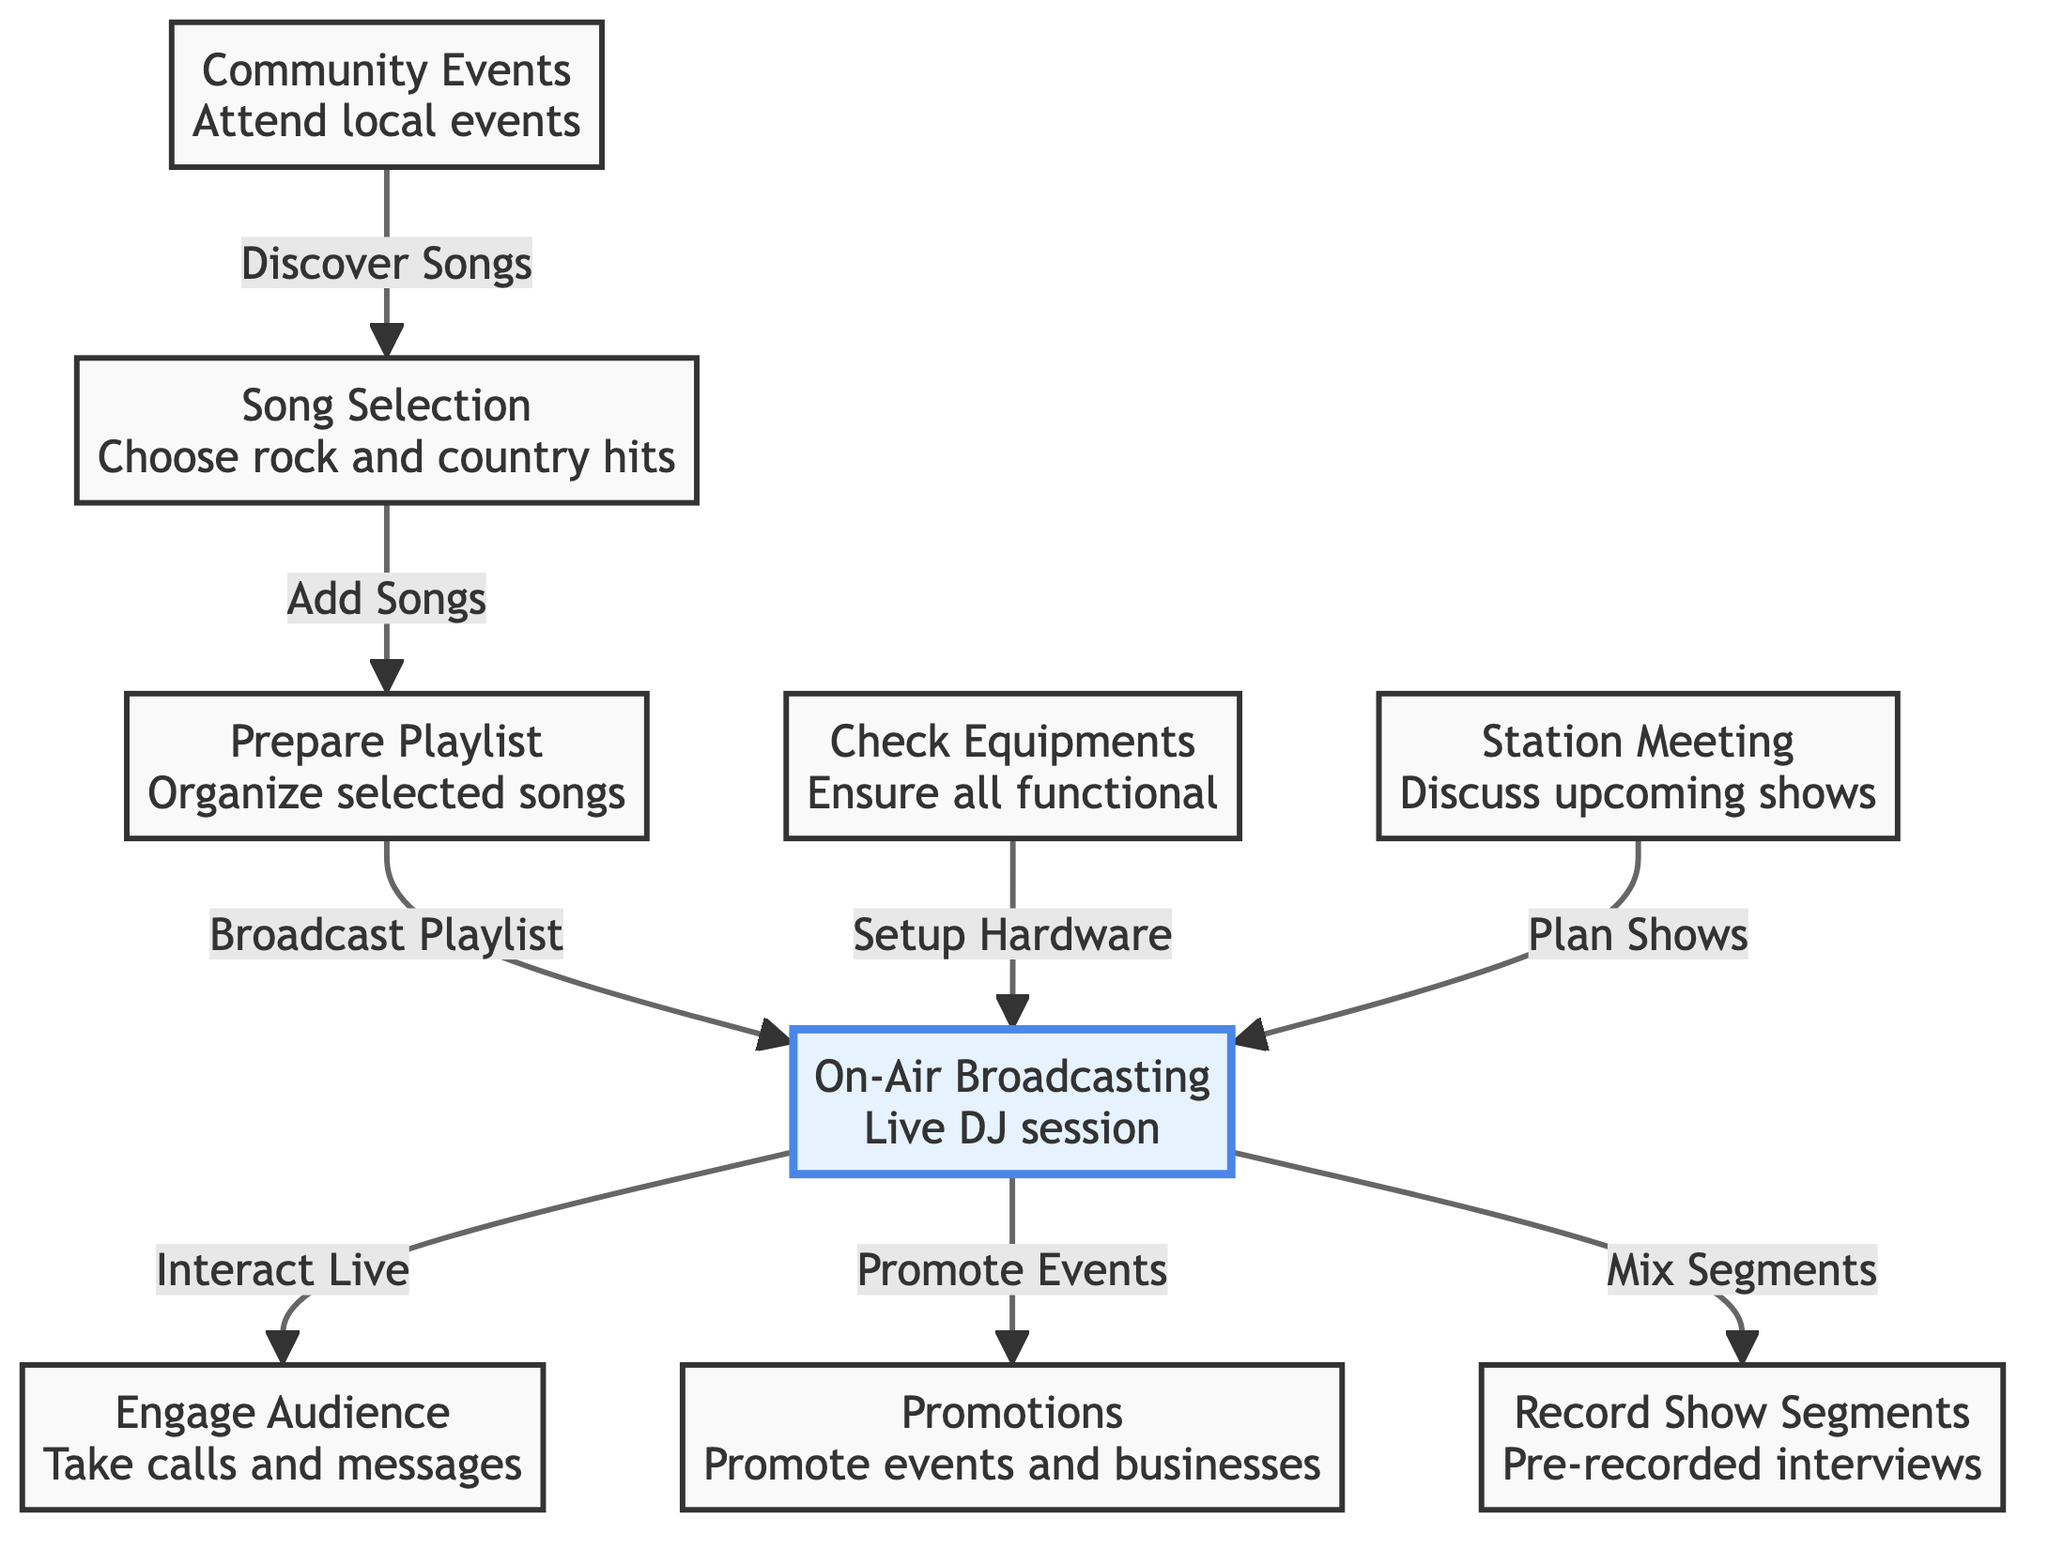What is the first step in the workflow for a local radio DJ? The first step indicated in the diagram is "Song Selection," where the DJ chooses rock and country hits.
Answer: Song Selection How many main activities are outlined in the workflow? The diagram lists 9 main activities, including song selection, playlist preparation, on-air broadcasting, equipment checking, audience engagement, promotions, segment recording, station meetings, and community events.
Answer: 9 Which activity directly precedes on-air broadcasting? The last activity that takes place before on-air broadcasting is "Prepare Playlist," which organizes the selected songs for broadcasting.
Answer: Prepare Playlist What role does the "Community Events" activity play in the workflow? "Community Events" serves to discover new songs for the music selection process, indicating a continual loop of inspiration from local events.
Answer: Discover Songs What is the relationship between "Check Equipments" and "On-Air Broadcasting"? "Check Equipments" is directly linked to "On-Air Broadcasting," indicating that equipment checking is a setup requirement for the broadcasting session.
Answer: Setup Hardware During the on-air broadcasting, what is one of the actions the DJ performs? During the on-air broadcasting, the DJ interacts live with the audience, which includes taking calls and messages.
Answer: Interact Live What additional elements does "On-Air Broadcasting" involve besides audience engagement? Besides engaging the audience, "On-Air Broadcasting" also involves promoting events and mixing recorded show segments.
Answer: Promote Events, Mix Segments Which activity follows the "Station Meeting"? The "Station Meeting" is connected to "On-Air Broadcasting," meaning that planning for shows occurs following the station meeting.
Answer: On-Air Broadcasting What is the last activity represented in the workflow? The diagram indicates "Community Events" as the last activity listed in the workflow for the local radio DJ.
Answer: Community Events 